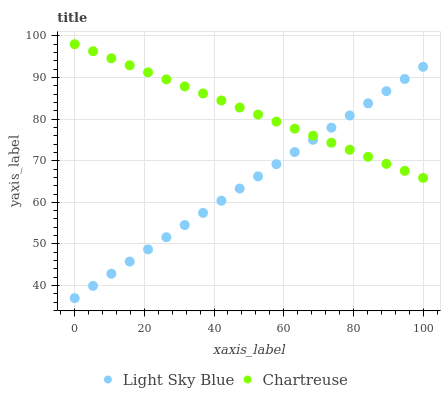Does Light Sky Blue have the minimum area under the curve?
Answer yes or no. Yes. Does Chartreuse have the maximum area under the curve?
Answer yes or no. Yes. Does Light Sky Blue have the maximum area under the curve?
Answer yes or no. No. Is Chartreuse the smoothest?
Answer yes or no. Yes. Is Light Sky Blue the roughest?
Answer yes or no. Yes. Is Light Sky Blue the smoothest?
Answer yes or no. No. Does Light Sky Blue have the lowest value?
Answer yes or no. Yes. Does Chartreuse have the highest value?
Answer yes or no. Yes. Does Light Sky Blue have the highest value?
Answer yes or no. No. Does Light Sky Blue intersect Chartreuse?
Answer yes or no. Yes. Is Light Sky Blue less than Chartreuse?
Answer yes or no. No. Is Light Sky Blue greater than Chartreuse?
Answer yes or no. No. 